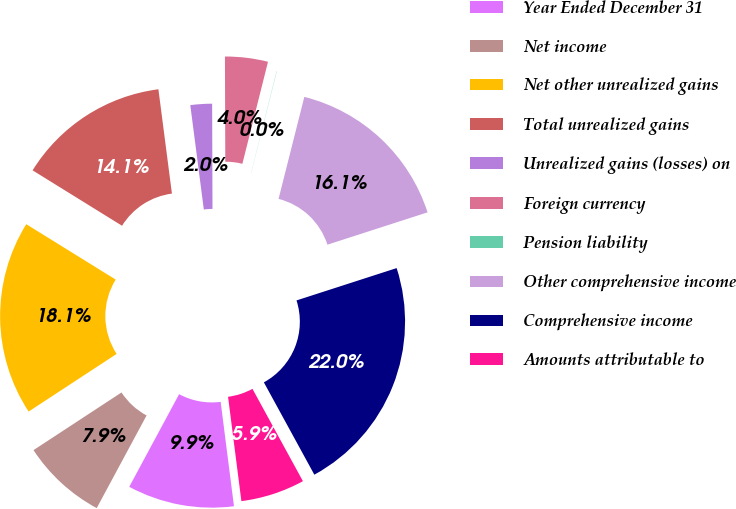Convert chart to OTSL. <chart><loc_0><loc_0><loc_500><loc_500><pie_chart><fcel>Year Ended December 31<fcel>Net income<fcel>Net other unrealized gains<fcel>Total unrealized gains<fcel>Unrealized gains (losses) on<fcel>Foreign currency<fcel>Pension liability<fcel>Other comprehensive income<fcel>Comprehensive income<fcel>Amounts attributable to<nl><fcel>9.88%<fcel>7.91%<fcel>18.06%<fcel>14.12%<fcel>2.0%<fcel>3.97%<fcel>0.02%<fcel>16.09%<fcel>22.01%<fcel>5.94%<nl></chart> 